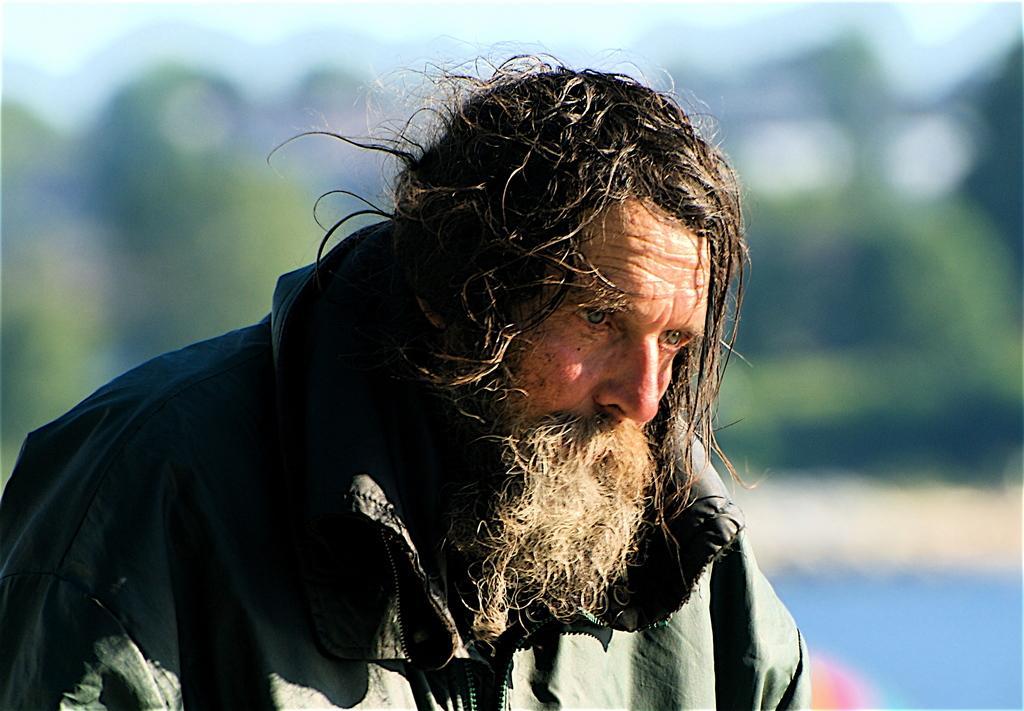Please provide a concise description of this image. In this picture I can see man and he wore a coat and I can see blurry background. 